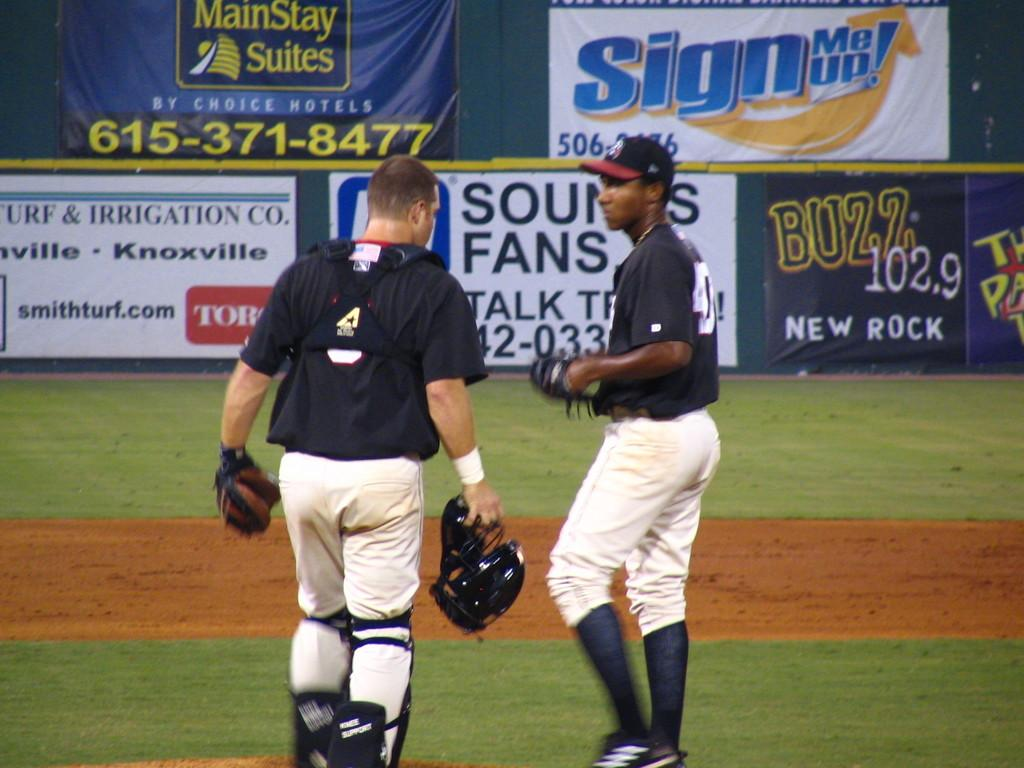Provide a one-sentence caption for the provided image. The catcher and pitcher of a black and white baseball team converse on the field in front signs advertising Buzz 102.9 and smithturf.com as well as others. 